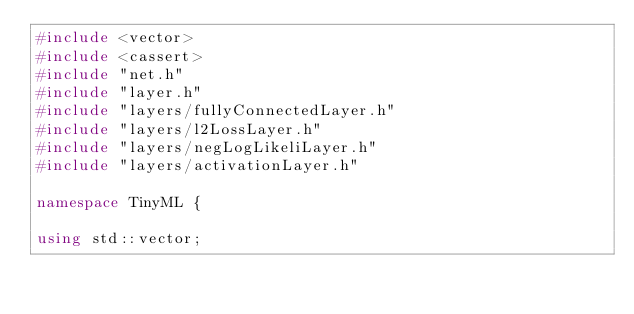Convert code to text. <code><loc_0><loc_0><loc_500><loc_500><_C++_>#include <vector>
#include <cassert>
#include "net.h"
#include "layer.h"
#include "layers/fullyConnectedLayer.h"
#include "layers/l2LossLayer.h"
#include "layers/negLogLikeliLayer.h"
#include "layers/activationLayer.h"

namespace TinyML {

using std::vector;
</code> 